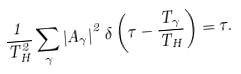Convert formula to latex. <formula><loc_0><loc_0><loc_500><loc_500>\frac { 1 } { T _ { H } ^ { 2 } } \sum _ { \gamma } \left | A _ { \gamma } \right | ^ { 2 } \delta \left ( \tau - \frac { T _ { \gamma } } { T _ { H } } \right ) = \tau .</formula> 